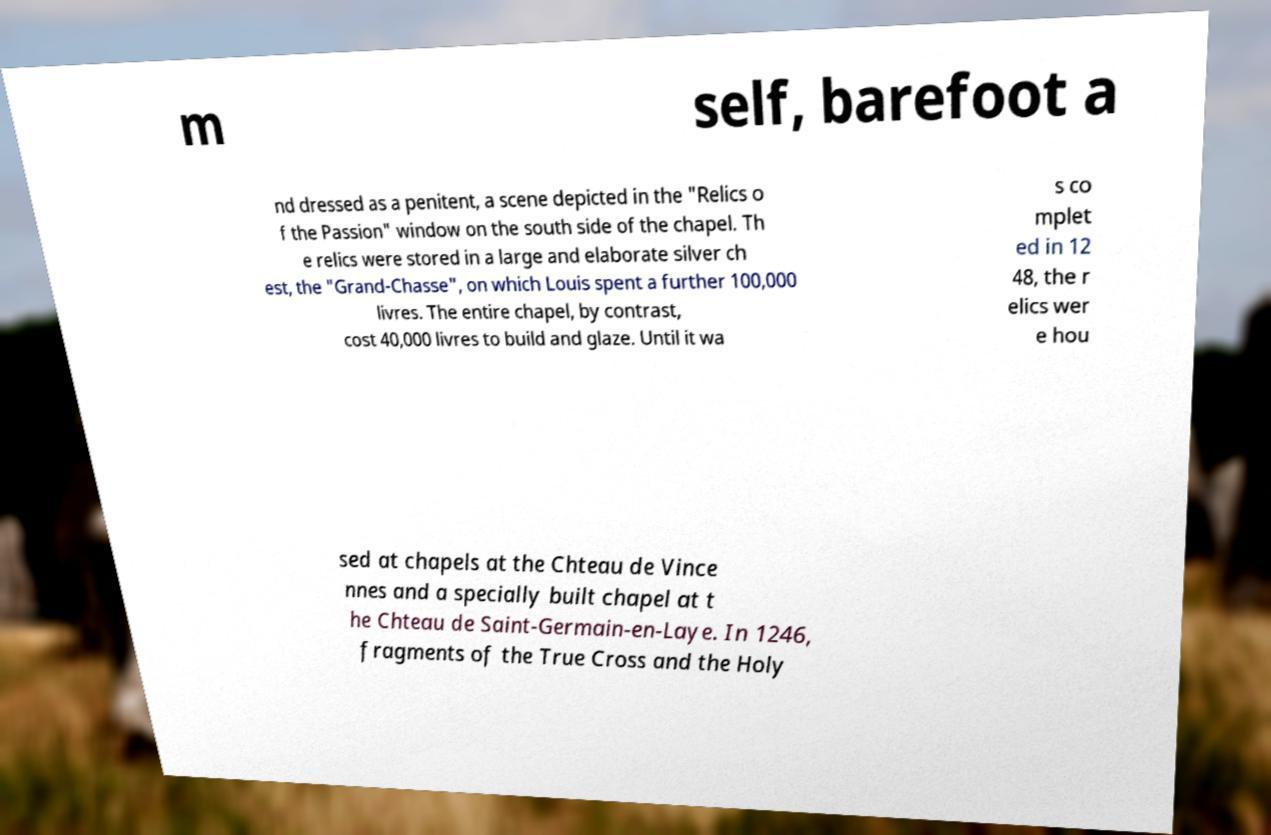Please identify and transcribe the text found in this image. m self, barefoot a nd dressed as a penitent, a scene depicted in the "Relics o f the Passion" window on the south side of the chapel. Th e relics were stored in a large and elaborate silver ch est, the "Grand-Chasse", on which Louis spent a further 100,000 livres. The entire chapel, by contrast, cost 40,000 livres to build and glaze. Until it wa s co mplet ed in 12 48, the r elics wer e hou sed at chapels at the Chteau de Vince nnes and a specially built chapel at t he Chteau de Saint-Germain-en-Laye. In 1246, fragments of the True Cross and the Holy 